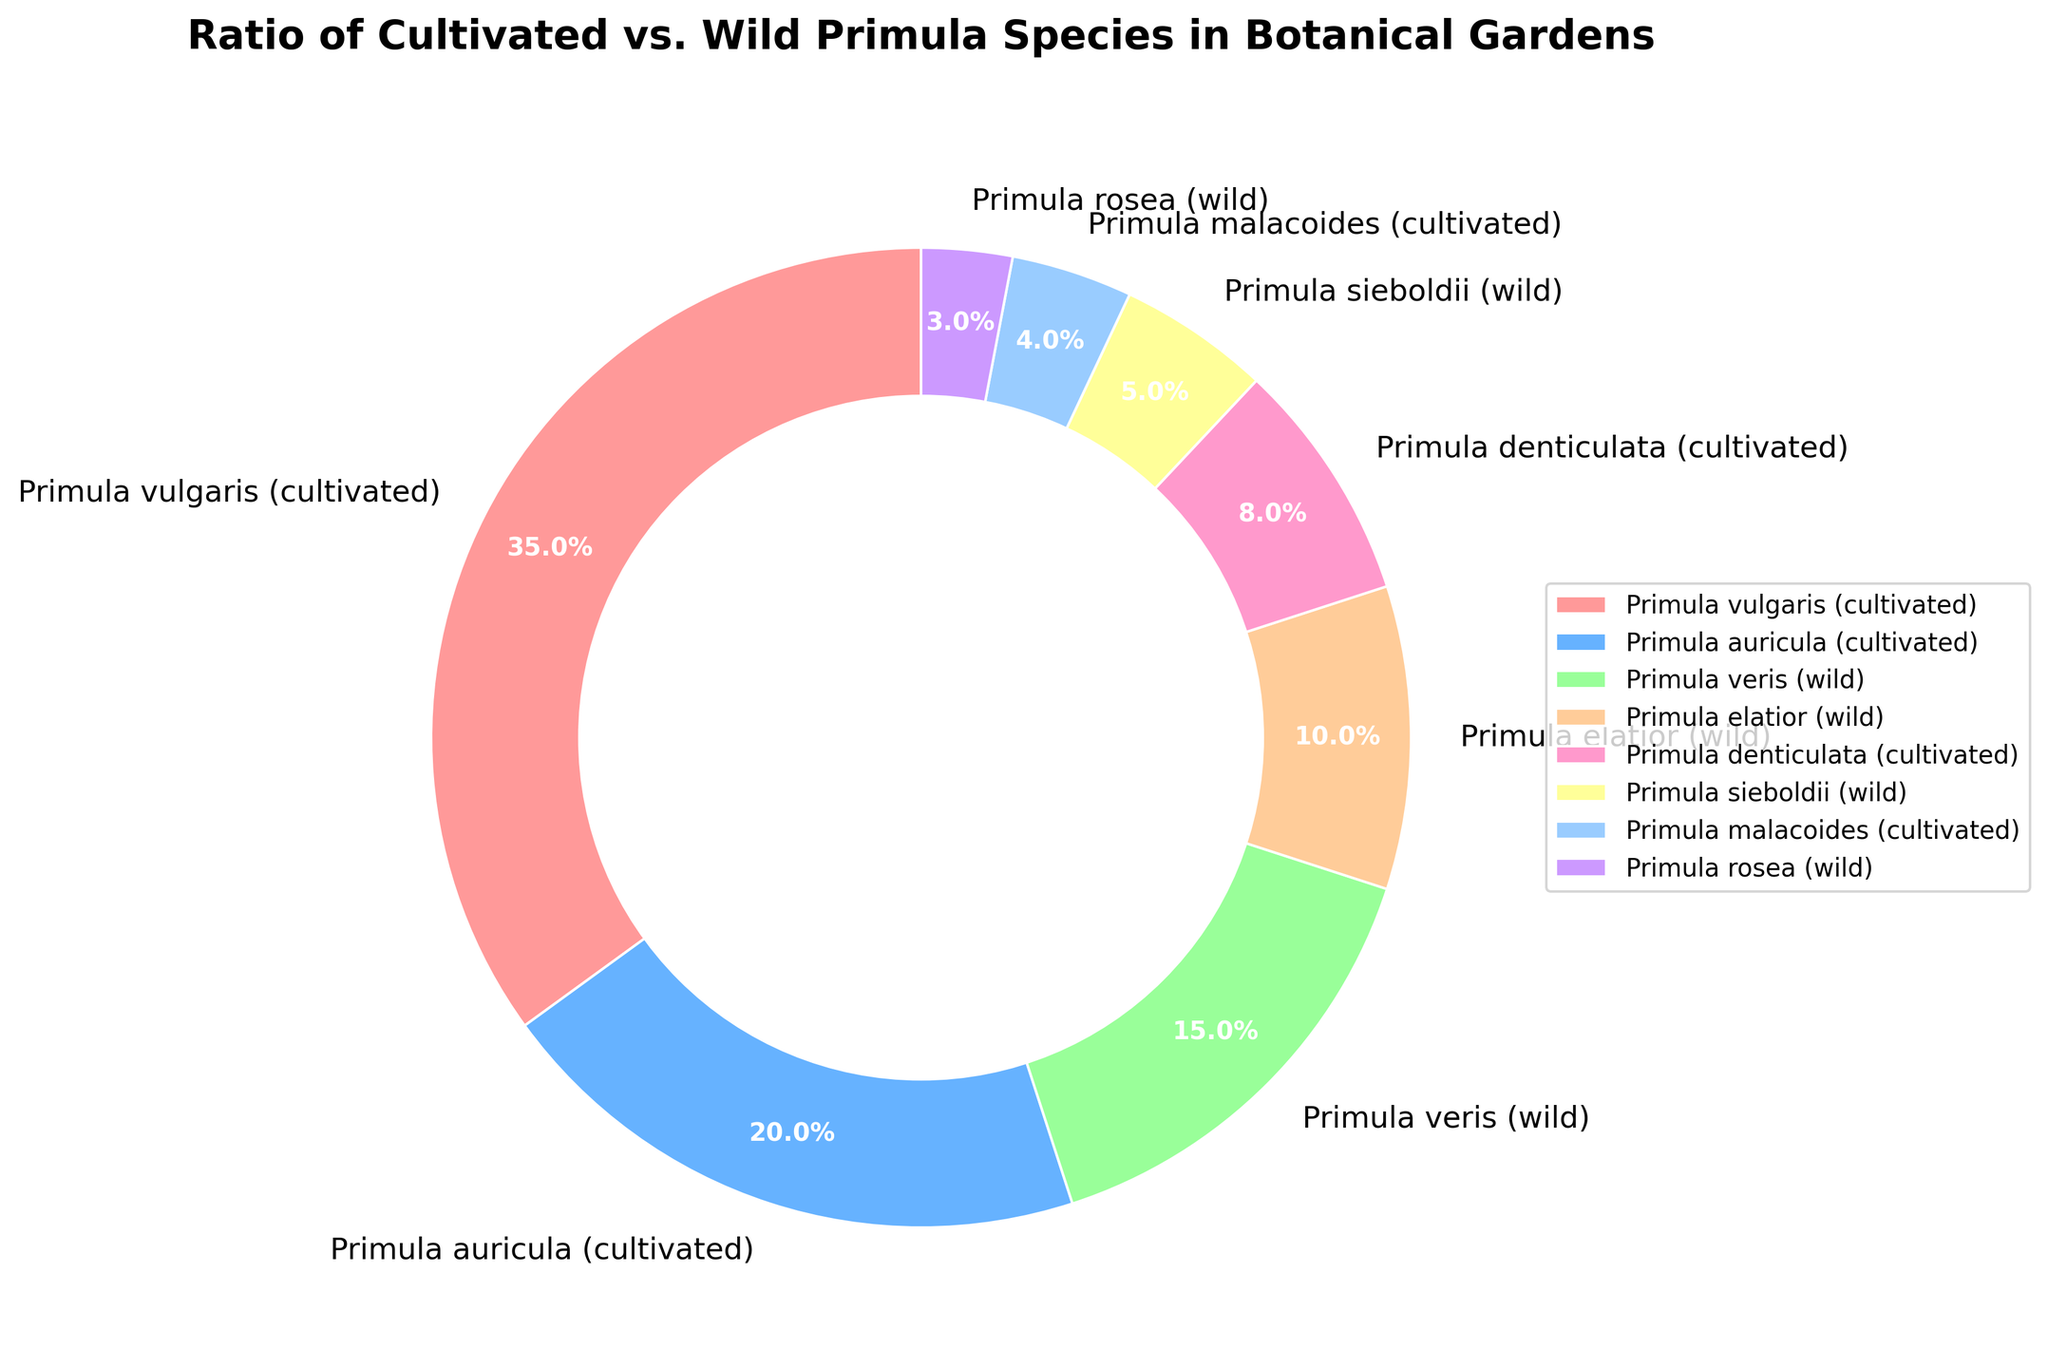What percentage of Primula species in botanical gardens are cultivated? By adding up the percentages of cultivated species: Primula vulgaris (35%), Primula auricula (20%), Primula denticulata (8%), and Primula malacoides (4%), we get 35 + 20 + 8 + 4 = 67%.
Answer: 67% Which Primula species has the highest percentage in the pie chart? Looking at the species with the largest segment, Primula vulgaris (cultivated) occupies 35% of the chart, which is the highest.
Answer: Primula vulgaris (cultivated) Are there more cultivated or wild Primula species in the botanical gardens? By comparing the total percentages, cultivated species make up 67% while wild species account for 33%. Hence, there are more cultivated species.
Answer: cultivated Which Primula species represents the smallest percentage, and what is it? The smallest segment corresponds to Primula rosea (wild), which represents 3% of the total.
Answer: Primula rosea (wild) What is the combined percentage of Primula veris (wild) and Primula sieboldii (wild)? Adding the percentages of Primula veris (15%) and Primula sieboldii (5%) gives us 15 + 5 = 20%.
Answer: 20% How does the percentage of Primula auricula (cultivated) compare to the percentage of Primula elatior (wild)? Primula auricula accounts for 20%, while Primula elatior accounts for 10%. Since 20% is greater than 10%, Primula auricula has a higher percentage.
Answer: greater Which color represents Primula denticulata (cultivated) in the pie chart? By matching the segments with the labels, Primula denticulata (cultivated) corresponds to the segment colored in light pink.
Answer: light pink What is the ratio of cultivated Primula species to wild Primula species? The percentages of cultivated and wild species are 67% and 33% respectively. The ratio is therefore 67:33, which simplifies to approximately 2:1.
Answer: 2:1 What is the average percentage of the wild Primula species presented in the chart? The wild species percentages are 15%, 10%, 5%, and 3%. Summing these gives 15 + 10 + 5 + 3 = 33. There are 4 wild species, so the average is 33/4 = 8.25%.
Answer: 8.25% How many species are represented in the pie chart? By counting the labels, there are 8 different Primula species represented in the chart.
Answer: 8 